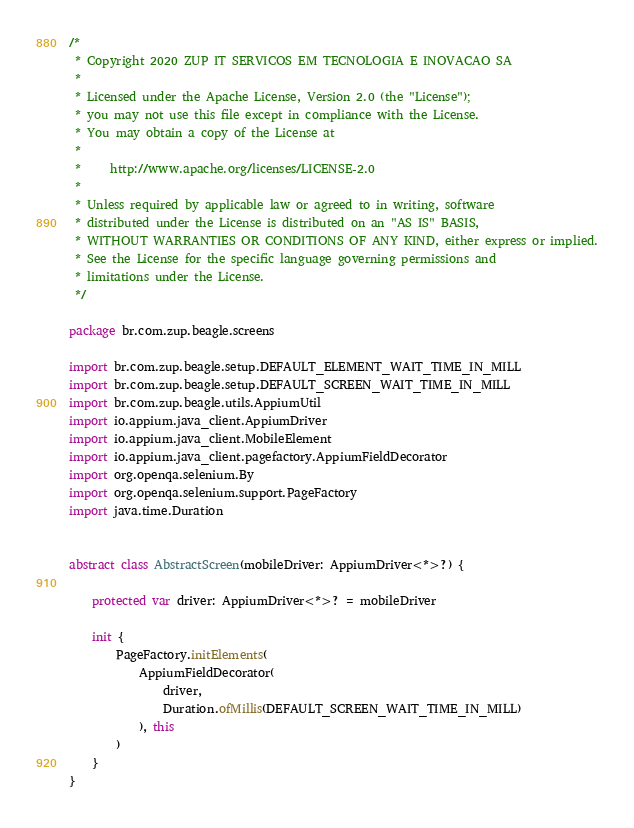Convert code to text. <code><loc_0><loc_0><loc_500><loc_500><_Kotlin_>/*
 * Copyright 2020 ZUP IT SERVICOS EM TECNOLOGIA E INOVACAO SA
 *
 * Licensed under the Apache License, Version 2.0 (the "License");
 * you may not use this file except in compliance with the License.
 * You may obtain a copy of the License at
 *
 *     http://www.apache.org/licenses/LICENSE-2.0
 *
 * Unless required by applicable law or agreed to in writing, software
 * distributed under the License is distributed on an "AS IS" BASIS,
 * WITHOUT WARRANTIES OR CONDITIONS OF ANY KIND, either express or implied.
 * See the License for the specific language governing permissions and
 * limitations under the License.
 */

package br.com.zup.beagle.screens

import br.com.zup.beagle.setup.DEFAULT_ELEMENT_WAIT_TIME_IN_MILL
import br.com.zup.beagle.setup.DEFAULT_SCREEN_WAIT_TIME_IN_MILL
import br.com.zup.beagle.utils.AppiumUtil
import io.appium.java_client.AppiumDriver
import io.appium.java_client.MobileElement
import io.appium.java_client.pagefactory.AppiumFieldDecorator
import org.openqa.selenium.By
import org.openqa.selenium.support.PageFactory
import java.time.Duration


abstract class AbstractScreen(mobileDriver: AppiumDriver<*>?) {

    protected var driver: AppiumDriver<*>? = mobileDriver

    init {
        PageFactory.initElements(
            AppiumFieldDecorator(
                driver,
                Duration.ofMillis(DEFAULT_SCREEN_WAIT_TIME_IN_MILL)
            ), this
        )
    }
}</code> 